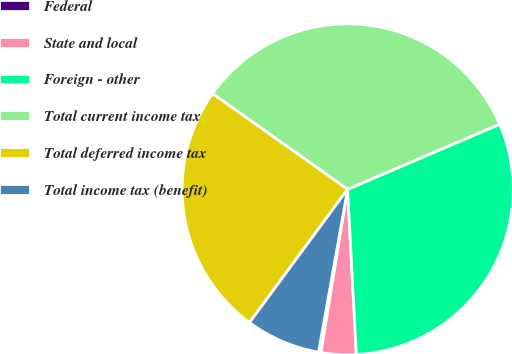Convert chart to OTSL. <chart><loc_0><loc_0><loc_500><loc_500><pie_chart><fcel>Federal<fcel>State and local<fcel>Foreign - other<fcel>Total current income tax<fcel>Total deferred income tax<fcel>Total income tax (benefit)<nl><fcel>0.24%<fcel>3.41%<fcel>30.59%<fcel>33.76%<fcel>24.71%<fcel>7.29%<nl></chart> 